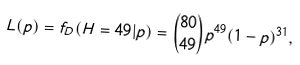<formula> <loc_0><loc_0><loc_500><loc_500>L ( p ) = f _ { D } ( H = 4 9 | p ) = { \binom { 8 0 } { 4 9 } } p ^ { 4 9 } ( 1 - p ) ^ { 3 1 } ,</formula> 